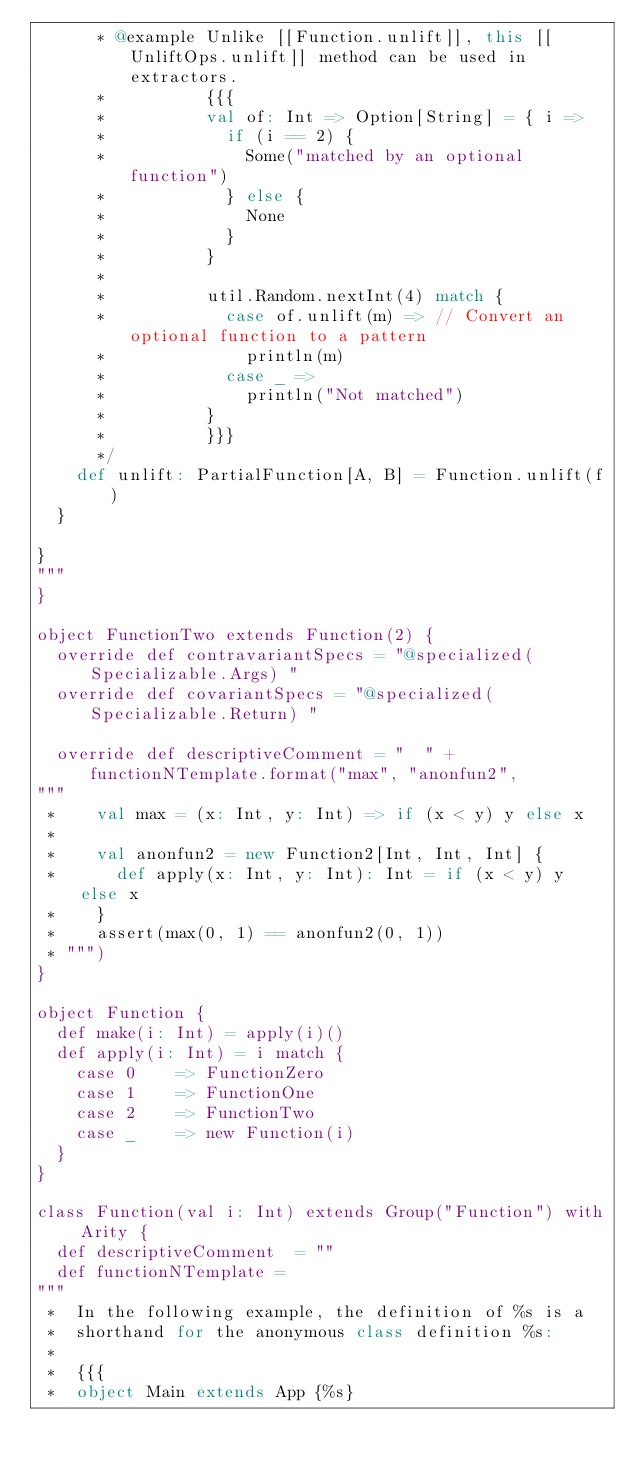Convert code to text. <code><loc_0><loc_0><loc_500><loc_500><_Scala_>      * @example Unlike [[Function.unlift]], this [[UnliftOps.unlift]] method can be used in extractors.
      *          {{{
      *          val of: Int => Option[String] = { i =>
      *            if (i == 2) {
      *              Some("matched by an optional function")
      *            } else {
      *              None
      *            }
      *          }
      *
      *          util.Random.nextInt(4) match {
      *            case of.unlift(m) => // Convert an optional function to a pattern
      *              println(m)
      *            case _ =>
      *              println("Not matched")
      *          }
      *          }}}
      */
    def unlift: PartialFunction[A, B] = Function.unlift(f)
  }

}
"""
}

object FunctionTwo extends Function(2) {
  override def contravariantSpecs = "@specialized(Specializable.Args) "
  override def covariantSpecs = "@specialized(Specializable.Return) "

  override def descriptiveComment = "  " + functionNTemplate.format("max", "anonfun2",
"""
 *    val max = (x: Int, y: Int) => if (x < y) y else x
 *
 *    val anonfun2 = new Function2[Int, Int, Int] {
 *      def apply(x: Int, y: Int): Int = if (x < y) y else x
 *    }
 *    assert(max(0, 1) == anonfun2(0, 1))
 * """)
}

object Function {
  def make(i: Int) = apply(i)()
  def apply(i: Int) = i match {
    case 0    => FunctionZero
    case 1    => FunctionOne
    case 2    => FunctionTwo
    case _    => new Function(i)
  }
}

class Function(val i: Int) extends Group("Function") with Arity {
  def descriptiveComment  = ""
  def functionNTemplate =
"""
 *  In the following example, the definition of %s is a
 *  shorthand for the anonymous class definition %s:
 *
 *  {{{
 *  object Main extends App {%s}</code> 